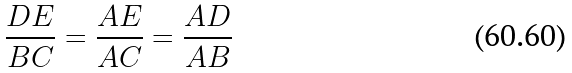<formula> <loc_0><loc_0><loc_500><loc_500>\frac { D E } { B C } = \frac { A E } { A C } = \frac { A D } { A B }</formula> 